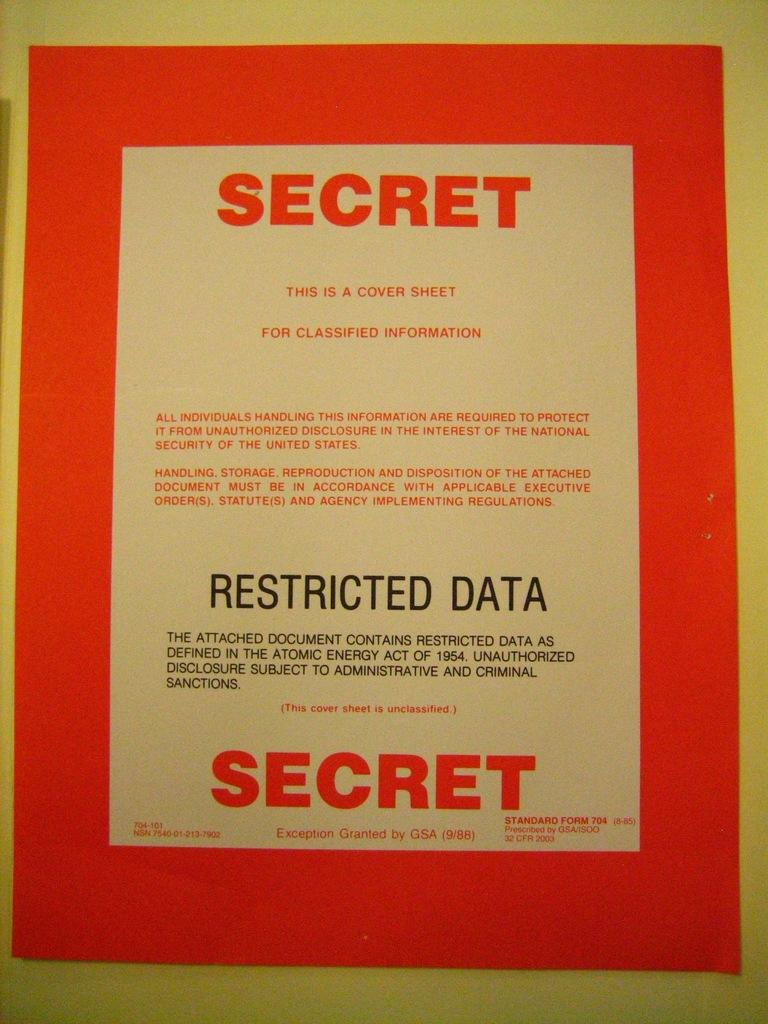<image>
Provide a brief description of the given image. a paper that has the word secret on it 